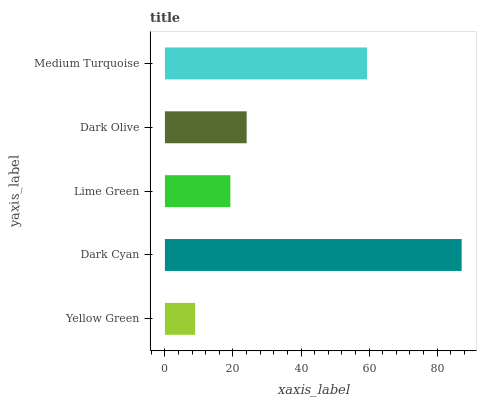Is Yellow Green the minimum?
Answer yes or no. Yes. Is Dark Cyan the maximum?
Answer yes or no. Yes. Is Lime Green the minimum?
Answer yes or no. No. Is Lime Green the maximum?
Answer yes or no. No. Is Dark Cyan greater than Lime Green?
Answer yes or no. Yes. Is Lime Green less than Dark Cyan?
Answer yes or no. Yes. Is Lime Green greater than Dark Cyan?
Answer yes or no. No. Is Dark Cyan less than Lime Green?
Answer yes or no. No. Is Dark Olive the high median?
Answer yes or no. Yes. Is Dark Olive the low median?
Answer yes or no. Yes. Is Yellow Green the high median?
Answer yes or no. No. Is Medium Turquoise the low median?
Answer yes or no. No. 